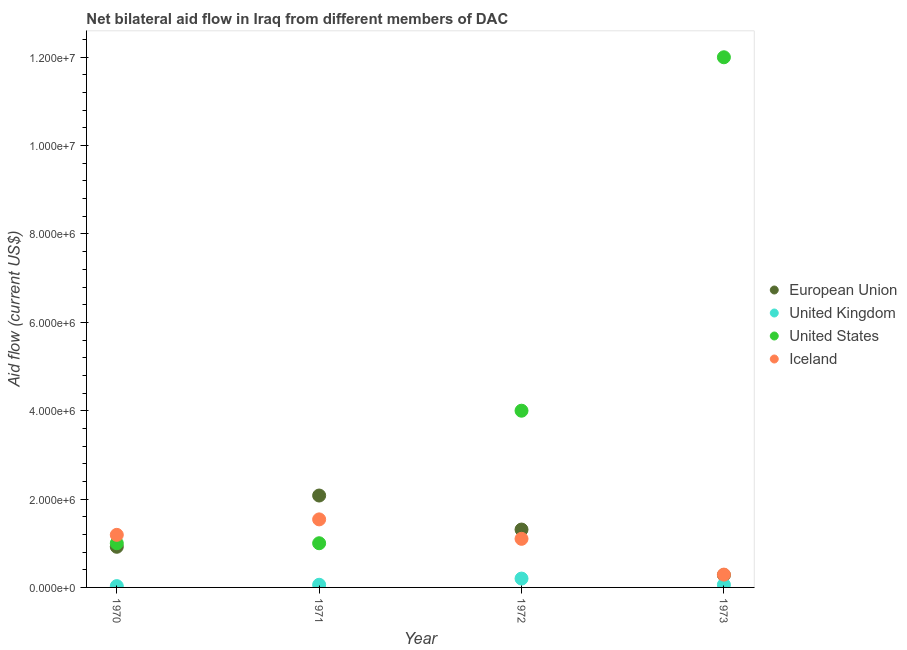How many different coloured dotlines are there?
Ensure brevity in your answer.  4. Is the number of dotlines equal to the number of legend labels?
Your answer should be very brief. Yes. What is the amount of aid given by eu in 1972?
Your answer should be compact. 1.31e+06. Across all years, what is the maximum amount of aid given by iceland?
Provide a succinct answer. 1.54e+06. Across all years, what is the minimum amount of aid given by us?
Provide a succinct answer. 1.00e+06. In which year was the amount of aid given by us minimum?
Ensure brevity in your answer.  1970. What is the total amount of aid given by iceland in the graph?
Ensure brevity in your answer.  4.12e+06. What is the difference between the amount of aid given by iceland in 1972 and that in 1973?
Keep it short and to the point. 8.10e+05. What is the difference between the amount of aid given by eu in 1973 and the amount of aid given by us in 1970?
Keep it short and to the point. -7.20e+05. What is the average amount of aid given by uk per year?
Your response must be concise. 8.75e+04. In the year 1973, what is the difference between the amount of aid given by us and amount of aid given by eu?
Give a very brief answer. 1.17e+07. What is the ratio of the amount of aid given by uk in 1970 to that in 1973?
Keep it short and to the point. 0.5. What is the difference between the highest and the lowest amount of aid given by us?
Your answer should be compact. 1.10e+07. In how many years, is the amount of aid given by eu greater than the average amount of aid given by eu taken over all years?
Provide a short and direct response. 2. Is it the case that in every year, the sum of the amount of aid given by eu and amount of aid given by us is greater than the sum of amount of aid given by iceland and amount of aid given by uk?
Make the answer very short. No. Is the amount of aid given by uk strictly greater than the amount of aid given by iceland over the years?
Provide a short and direct response. No. Is the amount of aid given by uk strictly less than the amount of aid given by us over the years?
Your response must be concise. Yes. How many dotlines are there?
Give a very brief answer. 4. What is the difference between two consecutive major ticks on the Y-axis?
Make the answer very short. 2.00e+06. Are the values on the major ticks of Y-axis written in scientific E-notation?
Your answer should be compact. Yes. Where does the legend appear in the graph?
Offer a very short reply. Center right. How many legend labels are there?
Your response must be concise. 4. What is the title of the graph?
Offer a very short reply. Net bilateral aid flow in Iraq from different members of DAC. Does "Secondary schools" appear as one of the legend labels in the graph?
Give a very brief answer. No. What is the label or title of the X-axis?
Make the answer very short. Year. What is the label or title of the Y-axis?
Ensure brevity in your answer.  Aid flow (current US$). What is the Aid flow (current US$) of European Union in 1970?
Provide a short and direct response. 9.20e+05. What is the Aid flow (current US$) of Iceland in 1970?
Keep it short and to the point. 1.19e+06. What is the Aid flow (current US$) in European Union in 1971?
Keep it short and to the point. 2.08e+06. What is the Aid flow (current US$) in Iceland in 1971?
Provide a short and direct response. 1.54e+06. What is the Aid flow (current US$) in European Union in 1972?
Your response must be concise. 1.31e+06. What is the Aid flow (current US$) in United Kingdom in 1972?
Your response must be concise. 2.00e+05. What is the Aid flow (current US$) of Iceland in 1972?
Offer a very short reply. 1.10e+06. What is the Aid flow (current US$) of United States in 1973?
Give a very brief answer. 1.20e+07. What is the Aid flow (current US$) of Iceland in 1973?
Make the answer very short. 2.90e+05. Across all years, what is the maximum Aid flow (current US$) of European Union?
Ensure brevity in your answer.  2.08e+06. Across all years, what is the maximum Aid flow (current US$) in United States?
Offer a very short reply. 1.20e+07. Across all years, what is the maximum Aid flow (current US$) in Iceland?
Your response must be concise. 1.54e+06. Across all years, what is the minimum Aid flow (current US$) in European Union?
Provide a succinct answer. 2.80e+05. Across all years, what is the minimum Aid flow (current US$) of United States?
Ensure brevity in your answer.  1.00e+06. Across all years, what is the minimum Aid flow (current US$) of Iceland?
Provide a short and direct response. 2.90e+05. What is the total Aid flow (current US$) of European Union in the graph?
Keep it short and to the point. 4.59e+06. What is the total Aid flow (current US$) of United Kingdom in the graph?
Give a very brief answer. 3.50e+05. What is the total Aid flow (current US$) of United States in the graph?
Keep it short and to the point. 1.80e+07. What is the total Aid flow (current US$) in Iceland in the graph?
Offer a terse response. 4.12e+06. What is the difference between the Aid flow (current US$) of European Union in 1970 and that in 1971?
Provide a short and direct response. -1.16e+06. What is the difference between the Aid flow (current US$) in United Kingdom in 1970 and that in 1971?
Your answer should be compact. -3.00e+04. What is the difference between the Aid flow (current US$) of United States in 1970 and that in 1971?
Offer a very short reply. 0. What is the difference between the Aid flow (current US$) of Iceland in 1970 and that in 1971?
Provide a short and direct response. -3.50e+05. What is the difference between the Aid flow (current US$) in European Union in 1970 and that in 1972?
Your answer should be very brief. -3.90e+05. What is the difference between the Aid flow (current US$) of Iceland in 1970 and that in 1972?
Offer a very short reply. 9.00e+04. What is the difference between the Aid flow (current US$) of European Union in 1970 and that in 1973?
Make the answer very short. 6.40e+05. What is the difference between the Aid flow (current US$) in United Kingdom in 1970 and that in 1973?
Your answer should be very brief. -3.00e+04. What is the difference between the Aid flow (current US$) in United States in 1970 and that in 1973?
Your answer should be very brief. -1.10e+07. What is the difference between the Aid flow (current US$) of European Union in 1971 and that in 1972?
Offer a terse response. 7.70e+05. What is the difference between the Aid flow (current US$) in United States in 1971 and that in 1972?
Your response must be concise. -3.00e+06. What is the difference between the Aid flow (current US$) of Iceland in 1971 and that in 1972?
Your answer should be very brief. 4.40e+05. What is the difference between the Aid flow (current US$) of European Union in 1971 and that in 1973?
Offer a very short reply. 1.80e+06. What is the difference between the Aid flow (current US$) of United Kingdom in 1971 and that in 1973?
Provide a succinct answer. 0. What is the difference between the Aid flow (current US$) of United States in 1971 and that in 1973?
Offer a terse response. -1.10e+07. What is the difference between the Aid flow (current US$) in Iceland in 1971 and that in 1973?
Offer a very short reply. 1.25e+06. What is the difference between the Aid flow (current US$) in European Union in 1972 and that in 1973?
Keep it short and to the point. 1.03e+06. What is the difference between the Aid flow (current US$) of United Kingdom in 1972 and that in 1973?
Your answer should be very brief. 1.40e+05. What is the difference between the Aid flow (current US$) of United States in 1972 and that in 1973?
Ensure brevity in your answer.  -8.00e+06. What is the difference between the Aid flow (current US$) in Iceland in 1972 and that in 1973?
Provide a succinct answer. 8.10e+05. What is the difference between the Aid flow (current US$) in European Union in 1970 and the Aid flow (current US$) in United Kingdom in 1971?
Provide a short and direct response. 8.60e+05. What is the difference between the Aid flow (current US$) in European Union in 1970 and the Aid flow (current US$) in United States in 1971?
Offer a very short reply. -8.00e+04. What is the difference between the Aid flow (current US$) in European Union in 1970 and the Aid flow (current US$) in Iceland in 1971?
Offer a very short reply. -6.20e+05. What is the difference between the Aid flow (current US$) of United Kingdom in 1970 and the Aid flow (current US$) of United States in 1971?
Make the answer very short. -9.70e+05. What is the difference between the Aid flow (current US$) in United Kingdom in 1970 and the Aid flow (current US$) in Iceland in 1971?
Give a very brief answer. -1.51e+06. What is the difference between the Aid flow (current US$) of United States in 1970 and the Aid flow (current US$) of Iceland in 1971?
Give a very brief answer. -5.40e+05. What is the difference between the Aid flow (current US$) in European Union in 1970 and the Aid flow (current US$) in United Kingdom in 1972?
Give a very brief answer. 7.20e+05. What is the difference between the Aid flow (current US$) in European Union in 1970 and the Aid flow (current US$) in United States in 1972?
Give a very brief answer. -3.08e+06. What is the difference between the Aid flow (current US$) in United Kingdom in 1970 and the Aid flow (current US$) in United States in 1972?
Give a very brief answer. -3.97e+06. What is the difference between the Aid flow (current US$) of United Kingdom in 1970 and the Aid flow (current US$) of Iceland in 1972?
Give a very brief answer. -1.07e+06. What is the difference between the Aid flow (current US$) of European Union in 1970 and the Aid flow (current US$) of United Kingdom in 1973?
Provide a short and direct response. 8.60e+05. What is the difference between the Aid flow (current US$) of European Union in 1970 and the Aid flow (current US$) of United States in 1973?
Provide a succinct answer. -1.11e+07. What is the difference between the Aid flow (current US$) of European Union in 1970 and the Aid flow (current US$) of Iceland in 1973?
Offer a terse response. 6.30e+05. What is the difference between the Aid flow (current US$) in United Kingdom in 1970 and the Aid flow (current US$) in United States in 1973?
Provide a succinct answer. -1.20e+07. What is the difference between the Aid flow (current US$) in United States in 1970 and the Aid flow (current US$) in Iceland in 1973?
Provide a succinct answer. 7.10e+05. What is the difference between the Aid flow (current US$) in European Union in 1971 and the Aid flow (current US$) in United Kingdom in 1972?
Keep it short and to the point. 1.88e+06. What is the difference between the Aid flow (current US$) in European Union in 1971 and the Aid flow (current US$) in United States in 1972?
Your answer should be compact. -1.92e+06. What is the difference between the Aid flow (current US$) in European Union in 1971 and the Aid flow (current US$) in Iceland in 1972?
Offer a terse response. 9.80e+05. What is the difference between the Aid flow (current US$) of United Kingdom in 1971 and the Aid flow (current US$) of United States in 1972?
Make the answer very short. -3.94e+06. What is the difference between the Aid flow (current US$) in United Kingdom in 1971 and the Aid flow (current US$) in Iceland in 1972?
Provide a succinct answer. -1.04e+06. What is the difference between the Aid flow (current US$) in European Union in 1971 and the Aid flow (current US$) in United Kingdom in 1973?
Your answer should be compact. 2.02e+06. What is the difference between the Aid flow (current US$) of European Union in 1971 and the Aid flow (current US$) of United States in 1973?
Offer a very short reply. -9.92e+06. What is the difference between the Aid flow (current US$) of European Union in 1971 and the Aid flow (current US$) of Iceland in 1973?
Provide a succinct answer. 1.79e+06. What is the difference between the Aid flow (current US$) of United Kingdom in 1971 and the Aid flow (current US$) of United States in 1973?
Make the answer very short. -1.19e+07. What is the difference between the Aid flow (current US$) of United Kingdom in 1971 and the Aid flow (current US$) of Iceland in 1973?
Provide a succinct answer. -2.30e+05. What is the difference between the Aid flow (current US$) in United States in 1971 and the Aid flow (current US$) in Iceland in 1973?
Your answer should be compact. 7.10e+05. What is the difference between the Aid flow (current US$) of European Union in 1972 and the Aid flow (current US$) of United Kingdom in 1973?
Offer a very short reply. 1.25e+06. What is the difference between the Aid flow (current US$) of European Union in 1972 and the Aid flow (current US$) of United States in 1973?
Your answer should be very brief. -1.07e+07. What is the difference between the Aid flow (current US$) of European Union in 1972 and the Aid flow (current US$) of Iceland in 1973?
Give a very brief answer. 1.02e+06. What is the difference between the Aid flow (current US$) in United Kingdom in 1972 and the Aid flow (current US$) in United States in 1973?
Your response must be concise. -1.18e+07. What is the difference between the Aid flow (current US$) of United Kingdom in 1972 and the Aid flow (current US$) of Iceland in 1973?
Offer a very short reply. -9.00e+04. What is the difference between the Aid flow (current US$) in United States in 1972 and the Aid flow (current US$) in Iceland in 1973?
Your answer should be very brief. 3.71e+06. What is the average Aid flow (current US$) of European Union per year?
Ensure brevity in your answer.  1.15e+06. What is the average Aid flow (current US$) in United Kingdom per year?
Your response must be concise. 8.75e+04. What is the average Aid flow (current US$) in United States per year?
Offer a very short reply. 4.50e+06. What is the average Aid flow (current US$) in Iceland per year?
Provide a succinct answer. 1.03e+06. In the year 1970, what is the difference between the Aid flow (current US$) in European Union and Aid flow (current US$) in United Kingdom?
Provide a succinct answer. 8.90e+05. In the year 1970, what is the difference between the Aid flow (current US$) in European Union and Aid flow (current US$) in Iceland?
Give a very brief answer. -2.70e+05. In the year 1970, what is the difference between the Aid flow (current US$) of United Kingdom and Aid flow (current US$) of United States?
Offer a terse response. -9.70e+05. In the year 1970, what is the difference between the Aid flow (current US$) in United Kingdom and Aid flow (current US$) in Iceland?
Provide a succinct answer. -1.16e+06. In the year 1970, what is the difference between the Aid flow (current US$) in United States and Aid flow (current US$) in Iceland?
Keep it short and to the point. -1.90e+05. In the year 1971, what is the difference between the Aid flow (current US$) of European Union and Aid flow (current US$) of United Kingdom?
Offer a terse response. 2.02e+06. In the year 1971, what is the difference between the Aid flow (current US$) in European Union and Aid flow (current US$) in United States?
Offer a very short reply. 1.08e+06. In the year 1971, what is the difference between the Aid flow (current US$) of European Union and Aid flow (current US$) of Iceland?
Offer a very short reply. 5.40e+05. In the year 1971, what is the difference between the Aid flow (current US$) in United Kingdom and Aid flow (current US$) in United States?
Offer a very short reply. -9.40e+05. In the year 1971, what is the difference between the Aid flow (current US$) of United Kingdom and Aid flow (current US$) of Iceland?
Give a very brief answer. -1.48e+06. In the year 1971, what is the difference between the Aid flow (current US$) in United States and Aid flow (current US$) in Iceland?
Ensure brevity in your answer.  -5.40e+05. In the year 1972, what is the difference between the Aid flow (current US$) of European Union and Aid flow (current US$) of United Kingdom?
Provide a short and direct response. 1.11e+06. In the year 1972, what is the difference between the Aid flow (current US$) in European Union and Aid flow (current US$) in United States?
Ensure brevity in your answer.  -2.69e+06. In the year 1972, what is the difference between the Aid flow (current US$) of European Union and Aid flow (current US$) of Iceland?
Offer a terse response. 2.10e+05. In the year 1972, what is the difference between the Aid flow (current US$) in United Kingdom and Aid flow (current US$) in United States?
Offer a very short reply. -3.80e+06. In the year 1972, what is the difference between the Aid flow (current US$) in United Kingdom and Aid flow (current US$) in Iceland?
Provide a short and direct response. -9.00e+05. In the year 1972, what is the difference between the Aid flow (current US$) in United States and Aid flow (current US$) in Iceland?
Keep it short and to the point. 2.90e+06. In the year 1973, what is the difference between the Aid flow (current US$) in European Union and Aid flow (current US$) in United States?
Make the answer very short. -1.17e+07. In the year 1973, what is the difference between the Aid flow (current US$) in United Kingdom and Aid flow (current US$) in United States?
Provide a succinct answer. -1.19e+07. In the year 1973, what is the difference between the Aid flow (current US$) in United Kingdom and Aid flow (current US$) in Iceland?
Your response must be concise. -2.30e+05. In the year 1973, what is the difference between the Aid flow (current US$) in United States and Aid flow (current US$) in Iceland?
Make the answer very short. 1.17e+07. What is the ratio of the Aid flow (current US$) in European Union in 1970 to that in 1971?
Provide a succinct answer. 0.44. What is the ratio of the Aid flow (current US$) in United Kingdom in 1970 to that in 1971?
Offer a terse response. 0.5. What is the ratio of the Aid flow (current US$) in United States in 1970 to that in 1971?
Make the answer very short. 1. What is the ratio of the Aid flow (current US$) in Iceland in 1970 to that in 1971?
Provide a short and direct response. 0.77. What is the ratio of the Aid flow (current US$) in European Union in 1970 to that in 1972?
Provide a succinct answer. 0.7. What is the ratio of the Aid flow (current US$) in Iceland in 1970 to that in 1972?
Make the answer very short. 1.08. What is the ratio of the Aid flow (current US$) in European Union in 1970 to that in 1973?
Your answer should be compact. 3.29. What is the ratio of the Aid flow (current US$) in United Kingdom in 1970 to that in 1973?
Ensure brevity in your answer.  0.5. What is the ratio of the Aid flow (current US$) in United States in 1970 to that in 1973?
Give a very brief answer. 0.08. What is the ratio of the Aid flow (current US$) of Iceland in 1970 to that in 1973?
Your response must be concise. 4.1. What is the ratio of the Aid flow (current US$) in European Union in 1971 to that in 1972?
Offer a very short reply. 1.59. What is the ratio of the Aid flow (current US$) of United States in 1971 to that in 1972?
Provide a short and direct response. 0.25. What is the ratio of the Aid flow (current US$) of European Union in 1971 to that in 1973?
Your response must be concise. 7.43. What is the ratio of the Aid flow (current US$) in United States in 1971 to that in 1973?
Offer a terse response. 0.08. What is the ratio of the Aid flow (current US$) in Iceland in 1971 to that in 1973?
Keep it short and to the point. 5.31. What is the ratio of the Aid flow (current US$) of European Union in 1972 to that in 1973?
Offer a terse response. 4.68. What is the ratio of the Aid flow (current US$) of United Kingdom in 1972 to that in 1973?
Offer a terse response. 3.33. What is the ratio of the Aid flow (current US$) of Iceland in 1972 to that in 1973?
Make the answer very short. 3.79. What is the difference between the highest and the second highest Aid flow (current US$) in European Union?
Offer a terse response. 7.70e+05. What is the difference between the highest and the second highest Aid flow (current US$) of United States?
Your answer should be very brief. 8.00e+06. What is the difference between the highest and the second highest Aid flow (current US$) in Iceland?
Provide a succinct answer. 3.50e+05. What is the difference between the highest and the lowest Aid flow (current US$) in European Union?
Your response must be concise. 1.80e+06. What is the difference between the highest and the lowest Aid flow (current US$) in United Kingdom?
Give a very brief answer. 1.70e+05. What is the difference between the highest and the lowest Aid flow (current US$) of United States?
Your answer should be compact. 1.10e+07. What is the difference between the highest and the lowest Aid flow (current US$) of Iceland?
Make the answer very short. 1.25e+06. 